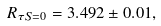Convert formula to latex. <formula><loc_0><loc_0><loc_500><loc_500>R _ { \tau S = 0 } = 3 . 4 9 2 \pm 0 . 0 1 ,</formula> 